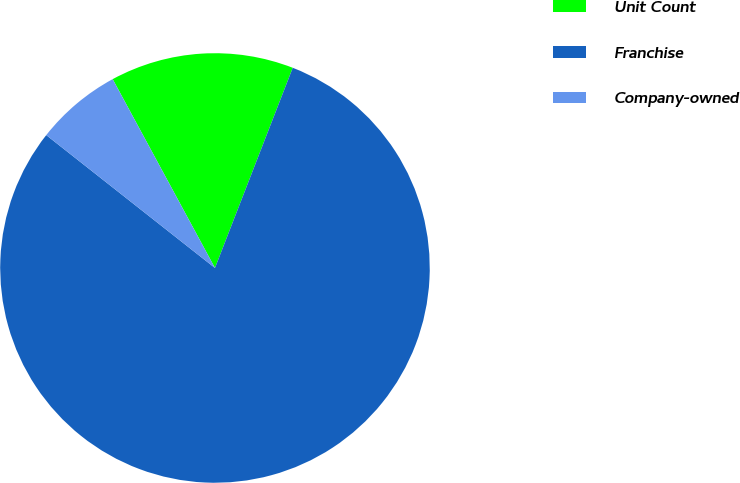Convert chart. <chart><loc_0><loc_0><loc_500><loc_500><pie_chart><fcel>Unit Count<fcel>Franchise<fcel>Company-owned<nl><fcel>13.8%<fcel>79.72%<fcel>6.48%<nl></chart> 